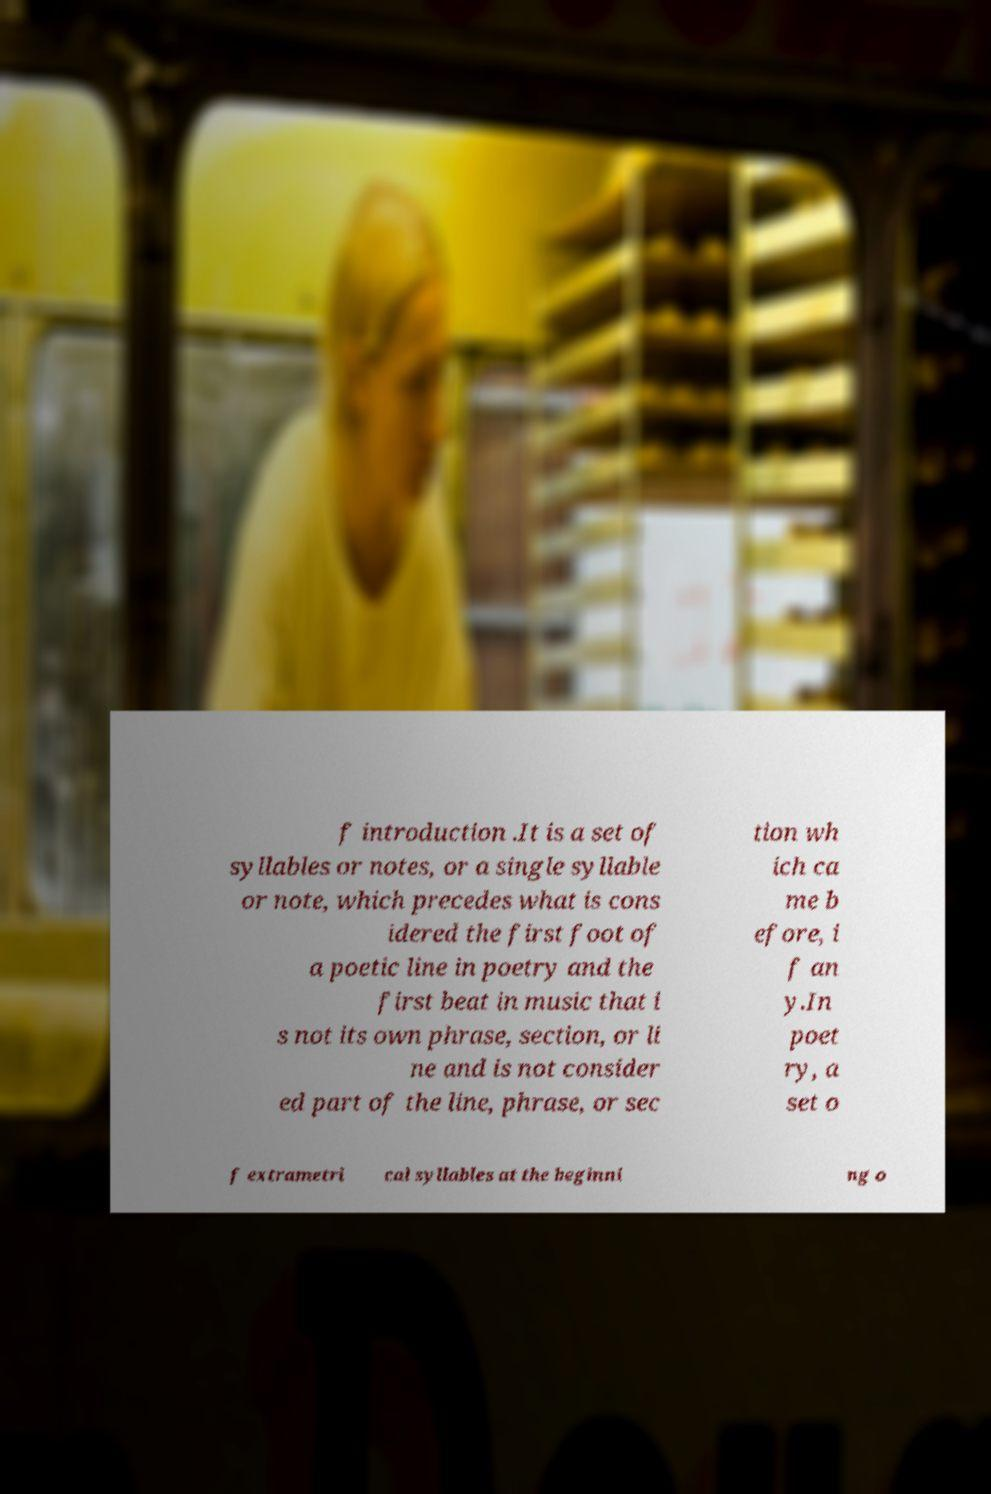Please read and relay the text visible in this image. What does it say? f introduction .It is a set of syllables or notes, or a single syllable or note, which precedes what is cons idered the first foot of a poetic line in poetry and the first beat in music that i s not its own phrase, section, or li ne and is not consider ed part of the line, phrase, or sec tion wh ich ca me b efore, i f an y.In poet ry, a set o f extrametri cal syllables at the beginni ng o 